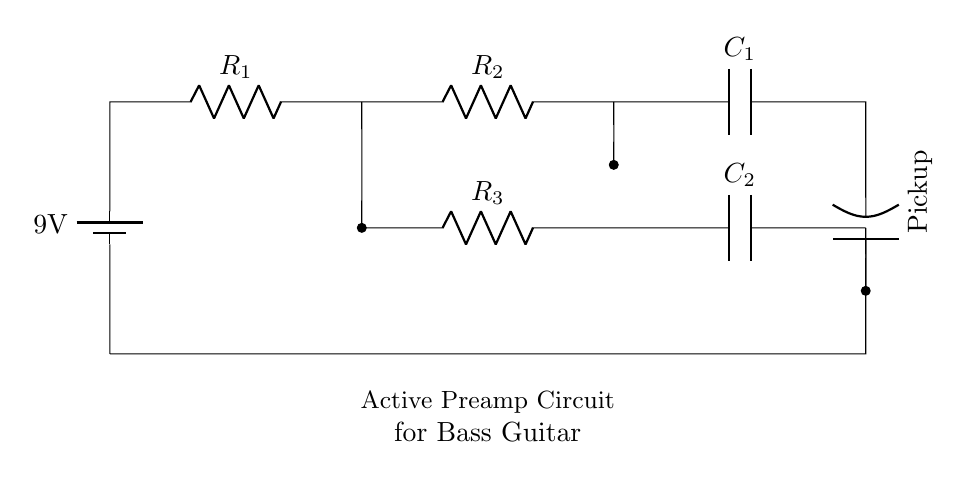What is the total voltage supplied in the circuit? The total voltage supplied in the circuit is the voltage of the battery. Here, the circuit uses a 9V battery, so the total voltage is 9V.
Answer: 9V What are the resistors labeled in this circuit? The resistors in the circuit are labeled as R1, R2, and R3. They are identified by the labels adjacent to each component in the diagram.
Answer: R1, R2, R3 How many capacitors are present in the circuit? The circuit contains two capacitors, C1 and C2, each identified by their respective labels in the diagram.
Answer: 2 What does the symbol labeled as "Pickup" represent? The label "Pickup" refers to the part of the circuit that converts the vibration of the bass strings into an electrical signal. It is located at the output of the circuit and indicated by the specific component symbol in the diagram.
Answer: Pickup Which resistor is connected directly to the battery? R1 is the resistor that is connected directly to the battery. It is the first component in the series after the battery, as shown in the circuit.
Answer: R1 What is the purpose of capacitor C2 in this circuit? Capacitor C2 is used for filtering or coupling purposes. It helps to stabilize the signal coming from the pickup and prevents unwanted noise, improving sound quality.
Answer: Filtering What type of circuit is illustrated in this diagram? The circuit is a series circuit, where all components are connected in a single path, allowing current to flow through each component sequentially. This is evident from the arrangement of the components in the diagram.
Answer: Series circuit 